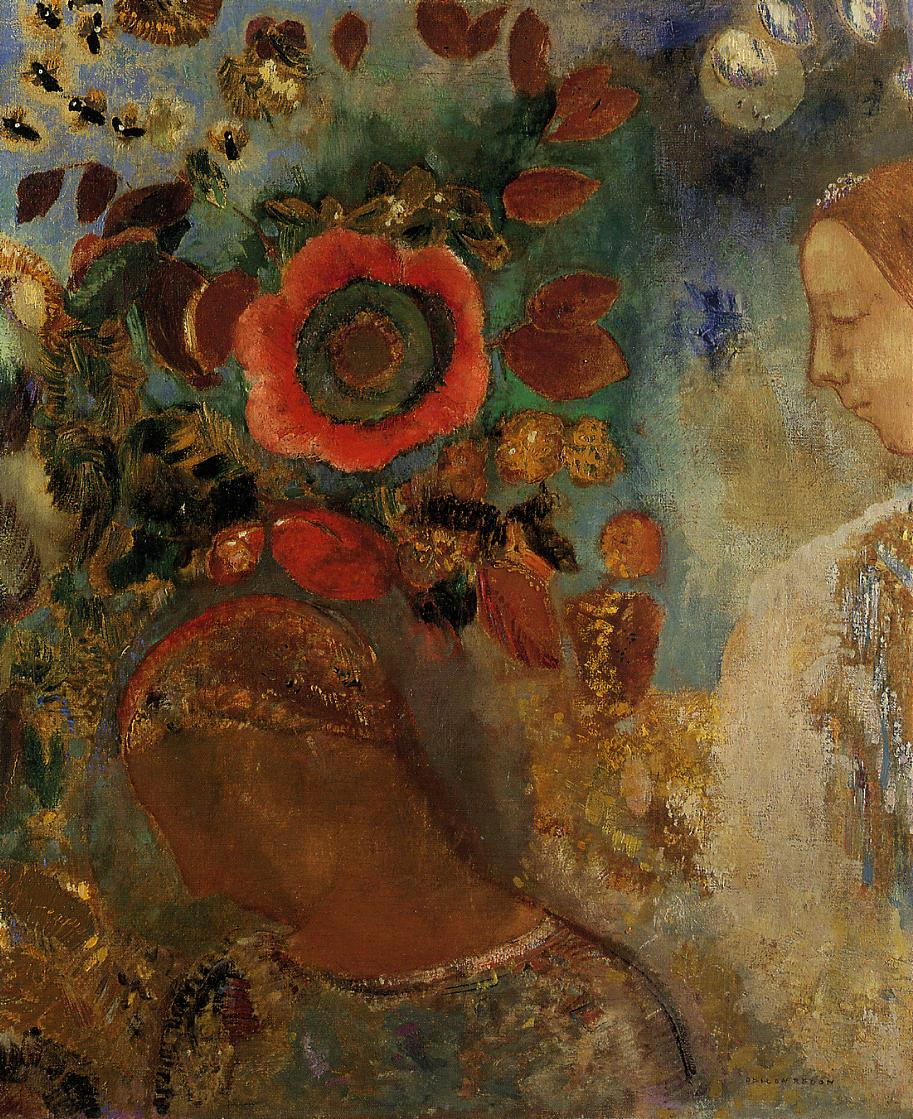Can you describe the main features of this image for me? The image depicts a serene woman in profile surrounded by a lively burst of nature. Her visage is tranquil and rendered in brown tones, suggesting a connection with the earthy surroundings. In a dazzling array of colors, a red flower takes center stage in the painting, symbolizing warmth and life, while smaller dabs of white, blue, and gold paint suggest other floral elements. Through the richness of the colors and the dynamic texture, this impressionistic artwork could be interpreted as a visual ode to the natural world and its harmonious relationship with humanity. The brushwork appears loose and expressive, creating an effect that is both dreamlike and vibrant, stirring emotions in the viewer. 